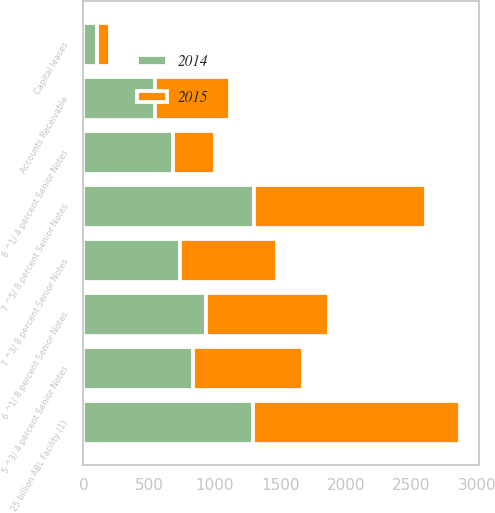<chart> <loc_0><loc_0><loc_500><loc_500><stacked_bar_chart><ecel><fcel>Accounts Receivable<fcel>25 billion ABL Facility (1)<fcel>7 ^3/ 8 percent Senior Notes<fcel>8 ^1/ 4 percent Senior Notes<fcel>7 ^5/ 8 percent Senior Notes<fcel>6 ^1/ 8 percent Senior Notes<fcel>5 ^3/ 4 percent Senior Notes<fcel>Capital leases<nl><fcel>2015<fcel>571<fcel>1579<fcel>740<fcel>315<fcel>1306<fcel>937<fcel>838<fcel>96<nl><fcel>2014<fcel>548<fcel>1293<fcel>738<fcel>687<fcel>1303<fcel>938<fcel>837<fcel>105<nl></chart> 